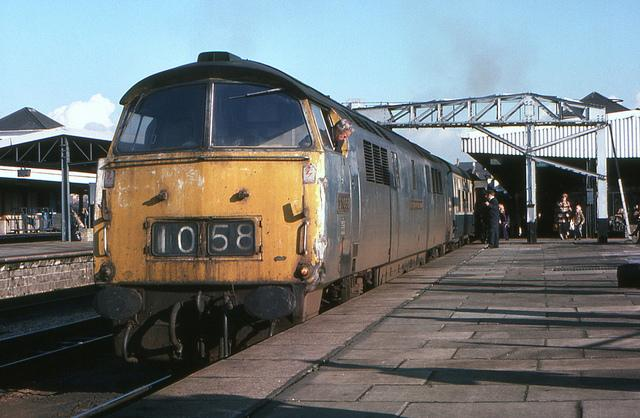What metro train number is this? Please explain your reasoning. 1058. The number 1058 is on the front of the train. 